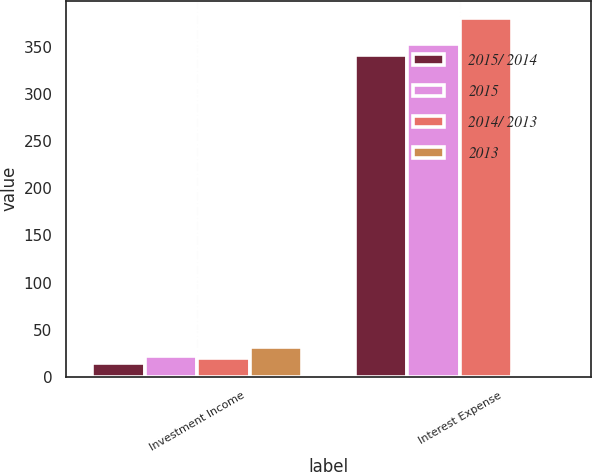Convert chart to OTSL. <chart><loc_0><loc_0><loc_500><loc_500><stacked_bar_chart><ecel><fcel>Investment Income<fcel>Interest Expense<nl><fcel>2015/ 2014<fcel>15<fcel>341<nl><fcel>2015<fcel>22<fcel>353<nl><fcel>2014/ 2013<fcel>20<fcel>380<nl><fcel>2013<fcel>31.8<fcel>3.4<nl></chart> 